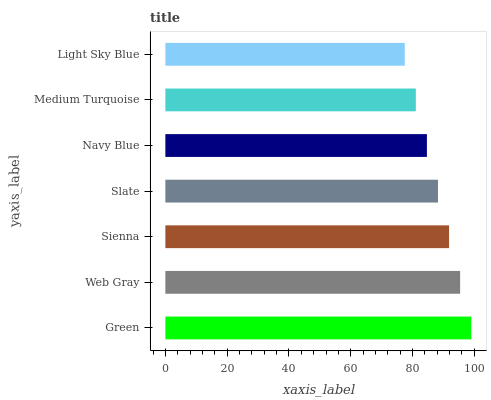Is Light Sky Blue the minimum?
Answer yes or no. Yes. Is Green the maximum?
Answer yes or no. Yes. Is Web Gray the minimum?
Answer yes or no. No. Is Web Gray the maximum?
Answer yes or no. No. Is Green greater than Web Gray?
Answer yes or no. Yes. Is Web Gray less than Green?
Answer yes or no. Yes. Is Web Gray greater than Green?
Answer yes or no. No. Is Green less than Web Gray?
Answer yes or no. No. Is Slate the high median?
Answer yes or no. Yes. Is Slate the low median?
Answer yes or no. Yes. Is Navy Blue the high median?
Answer yes or no. No. Is Sienna the low median?
Answer yes or no. No. 